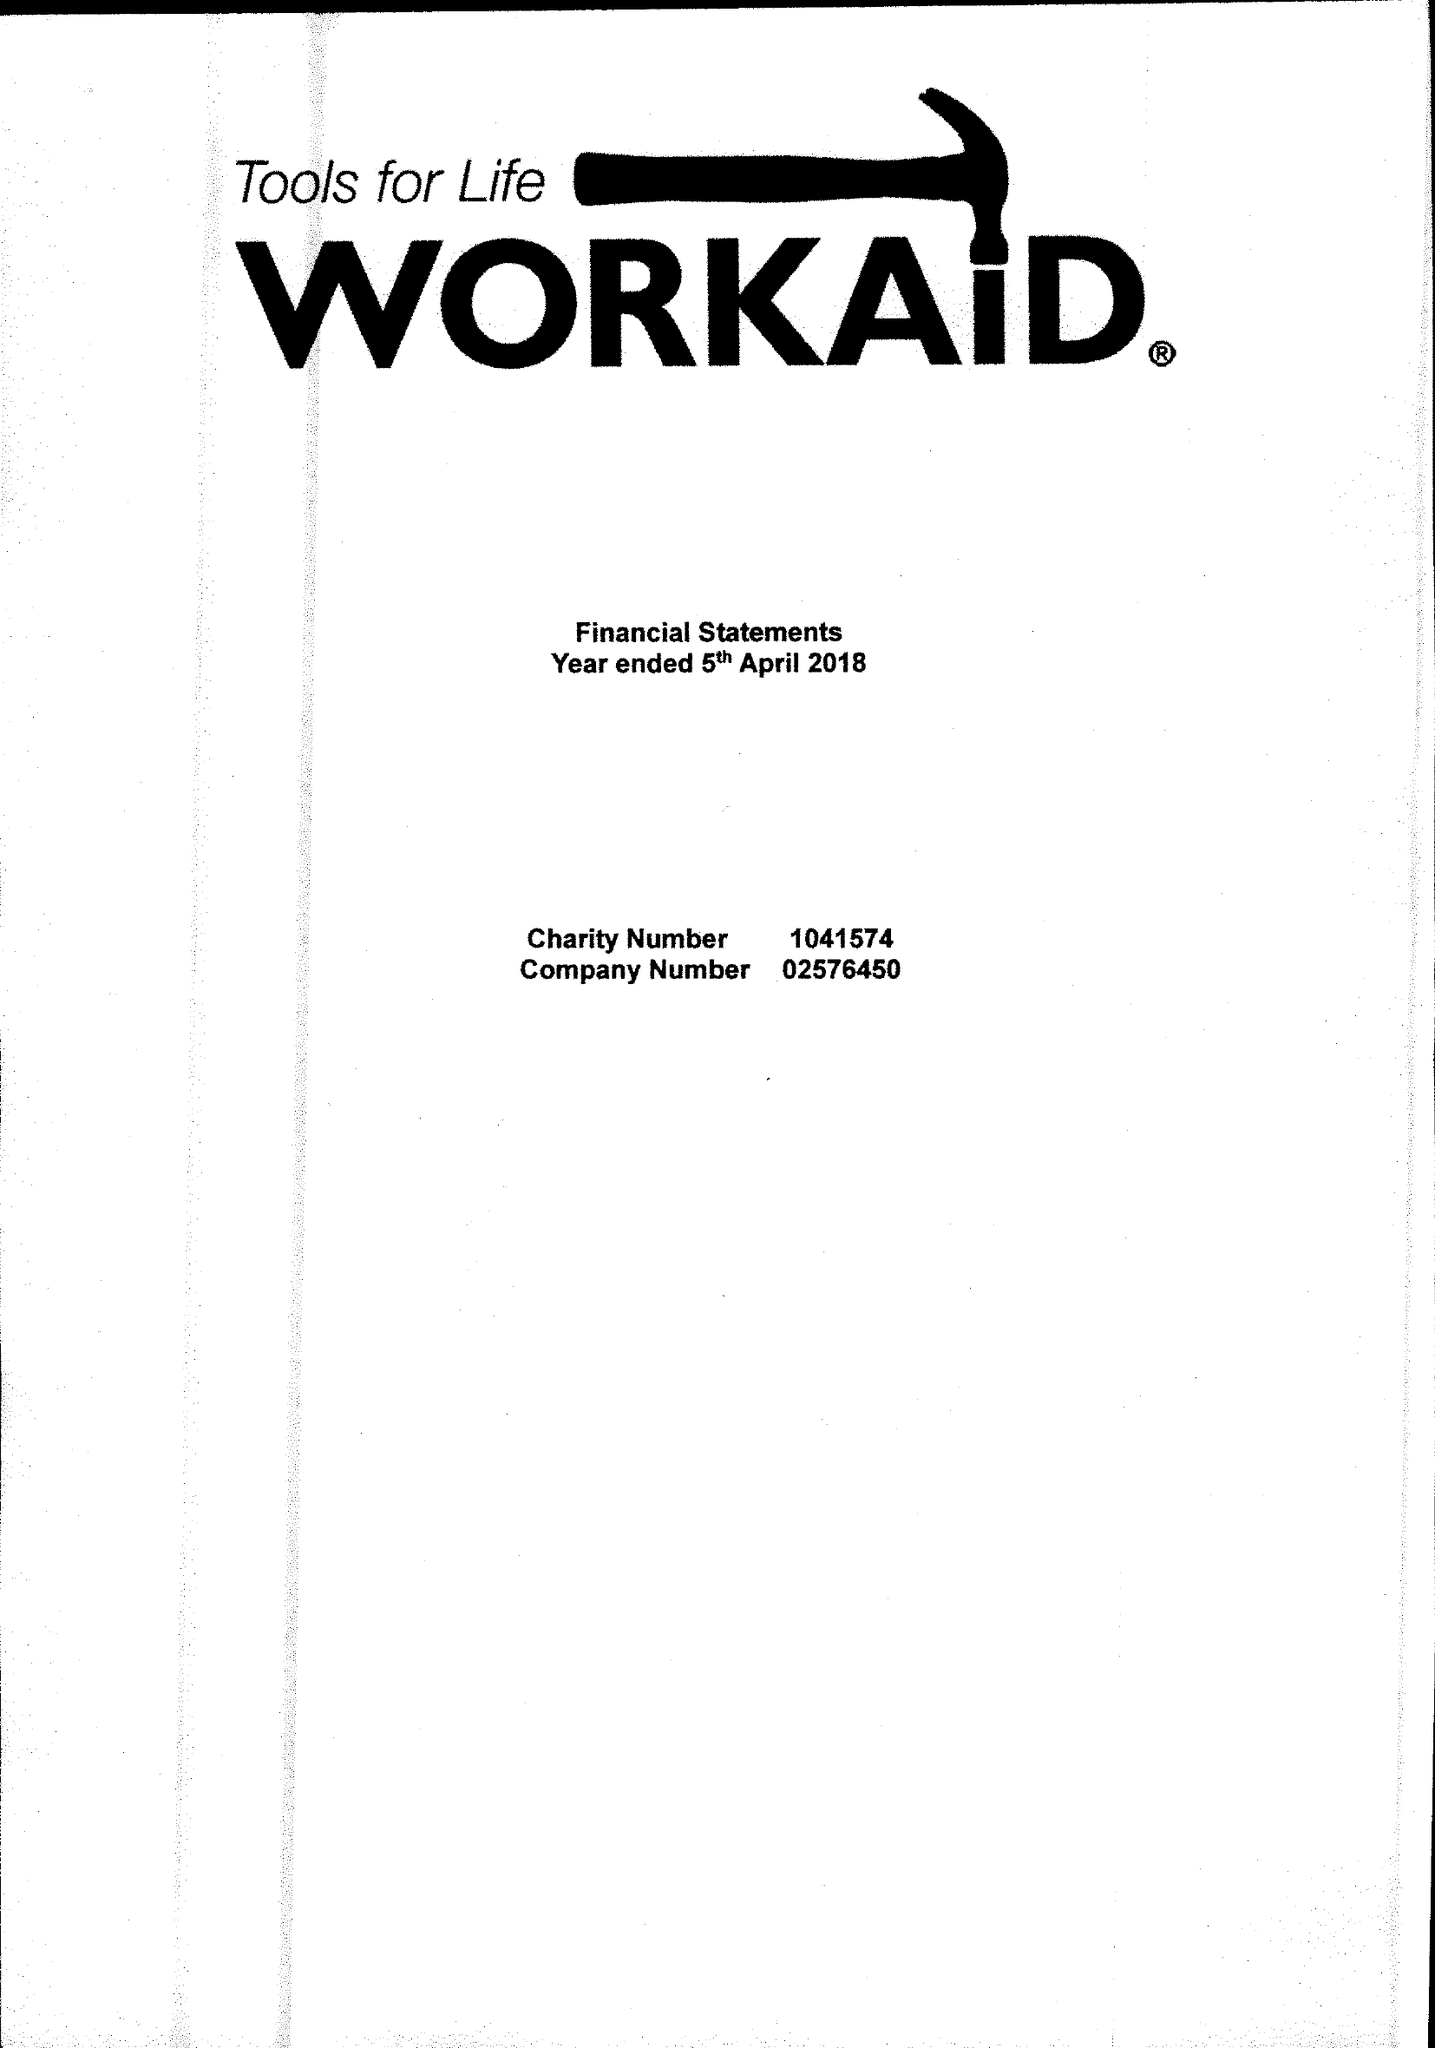What is the value for the spending_annually_in_british_pounds?
Answer the question using a single word or phrase. 338222.00 